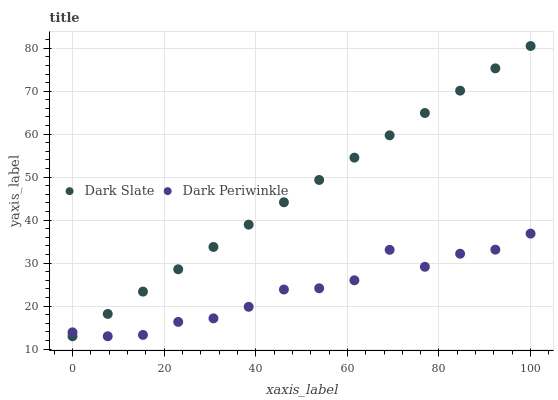Does Dark Periwinkle have the minimum area under the curve?
Answer yes or no. Yes. Does Dark Slate have the maximum area under the curve?
Answer yes or no. Yes. Does Dark Periwinkle have the maximum area under the curve?
Answer yes or no. No. Is Dark Slate the smoothest?
Answer yes or no. Yes. Is Dark Periwinkle the roughest?
Answer yes or no. Yes. Is Dark Periwinkle the smoothest?
Answer yes or no. No. Does Dark Slate have the lowest value?
Answer yes or no. Yes. Does Dark Slate have the highest value?
Answer yes or no. Yes. Does Dark Periwinkle have the highest value?
Answer yes or no. No. Does Dark Slate intersect Dark Periwinkle?
Answer yes or no. Yes. Is Dark Slate less than Dark Periwinkle?
Answer yes or no. No. Is Dark Slate greater than Dark Periwinkle?
Answer yes or no. No. 